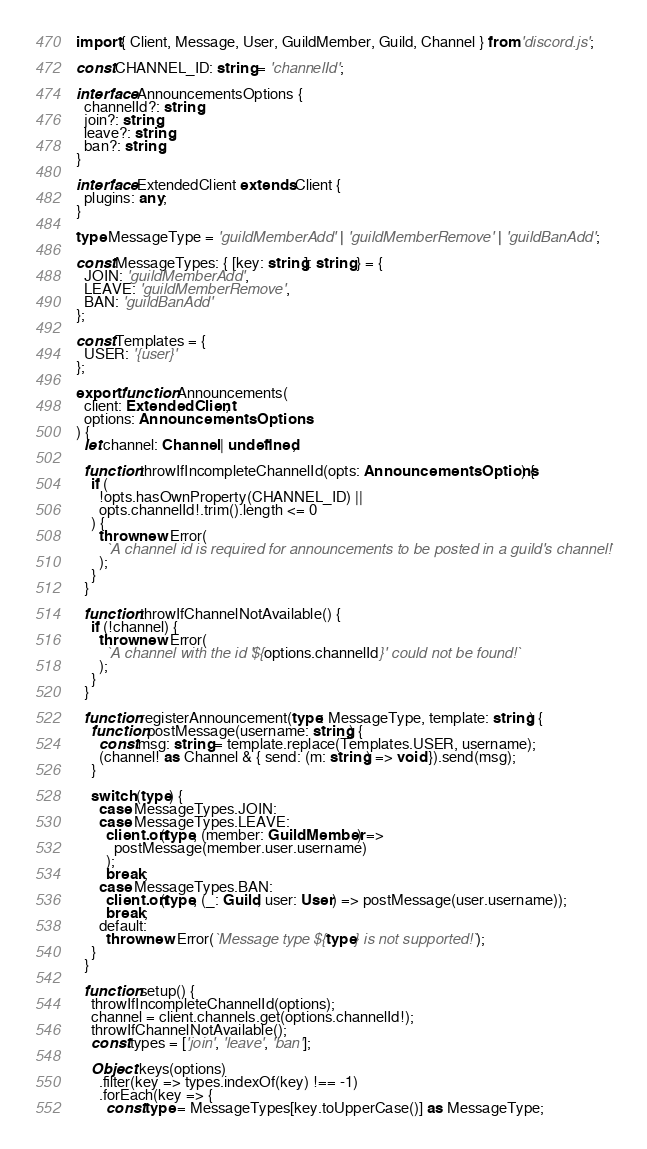Convert code to text. <code><loc_0><loc_0><loc_500><loc_500><_TypeScript_>import { Client, Message, User, GuildMember, Guild, Channel } from 'discord.js';

const CHANNEL_ID: string = 'channelId';

interface AnnouncementsOptions {
  channelId?: string;
  join?: string;
  leave?: string;
  ban?: string;
}

interface ExtendedClient extends Client {
  plugins: any;
}

type MessageType = 'guildMemberAdd' | 'guildMemberRemove' | 'guildBanAdd';

const MessageTypes: { [key: string]: string } = {
  JOIN: 'guildMemberAdd',
  LEAVE: 'guildMemberRemove',
  BAN: 'guildBanAdd'
};

const Templates = {
  USER: '{user}'
};

export function Announcements(
  client: ExtendedClient,
  options: AnnouncementsOptions
) {
  let channel: Channel | undefined;

  function throwIfIncompleteChannelId(opts: AnnouncementsOptions) {
    if (
      !opts.hasOwnProperty(CHANNEL_ID) ||
      opts.channelId!.trim().length <= 0
    ) {
      throw new Error(
        `A channel id is required for announcements to be posted in a guild's channel!`
      );
    }
  }

  function throwIfChannelNotAvailable() {
    if (!channel) {
      throw new Error(
        `A channel with the id '${options.channelId}' could not be found!`
      );
    }
  }

  function registerAnnouncement(type: MessageType, template: string) {
    function postMessage(username: string) {
      const msg: string = template.replace(Templates.USER, username);
      (channel! as Channel & { send: (m: string) => void }).send(msg);
    }

    switch (type) {
      case MessageTypes.JOIN:
      case MessageTypes.LEAVE:
        client.on(type, (member: GuildMember) =>
          postMessage(member.user.username)
        );
        break;
      case MessageTypes.BAN:
        client.on(type, (_: Guild, user: User) => postMessage(user.username));
        break;
      default:
        throw new Error(`Message type ${type} is not supported!`);
    }
  }

  function setup() {
    throwIfIncompleteChannelId(options);
    channel = client.channels.get(options.channelId!);
    throwIfChannelNotAvailable();
    const types = ['join', 'leave', 'ban'];

    Object.keys(options)
      .filter(key => types.indexOf(key) !== -1)
      .forEach(key => {
        const type = MessageTypes[key.toUpperCase()] as MessageType;</code> 